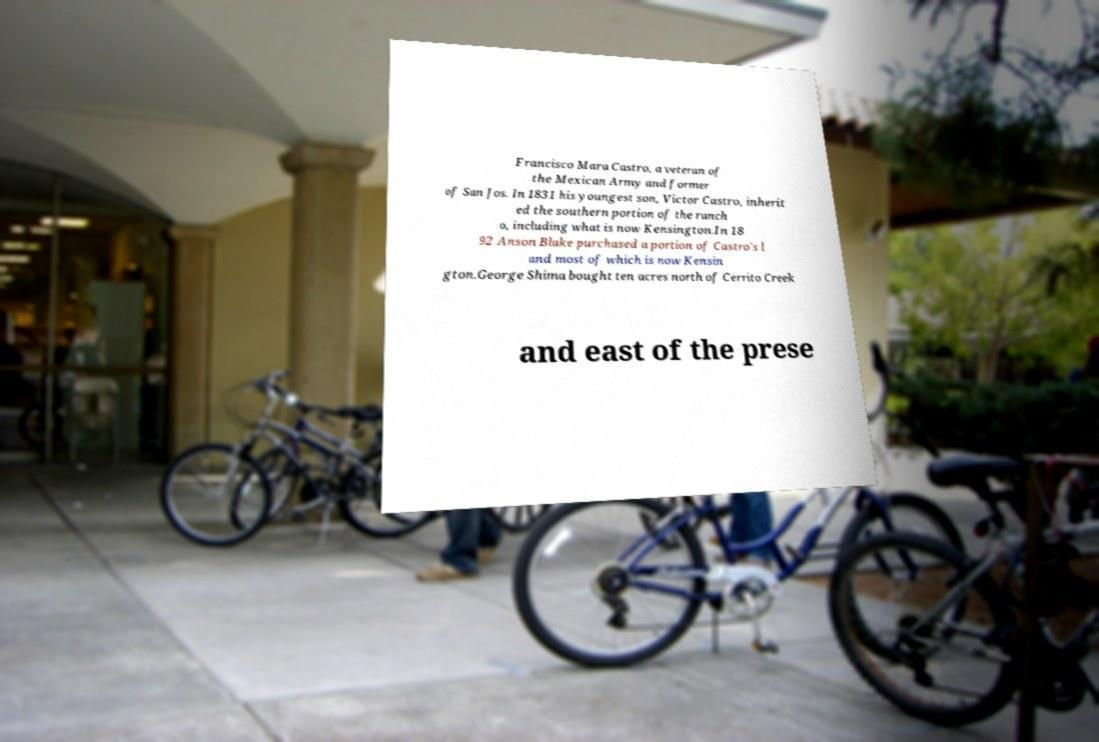For documentation purposes, I need the text within this image transcribed. Could you provide that? Francisco Mara Castro, a veteran of the Mexican Army and former of San Jos. In 1831 his youngest son, Victor Castro, inherit ed the southern portion of the ranch o, including what is now Kensington.In 18 92 Anson Blake purchased a portion of Castro's l and most of which is now Kensin gton.George Shima bought ten acres north of Cerrito Creek and east of the prese 